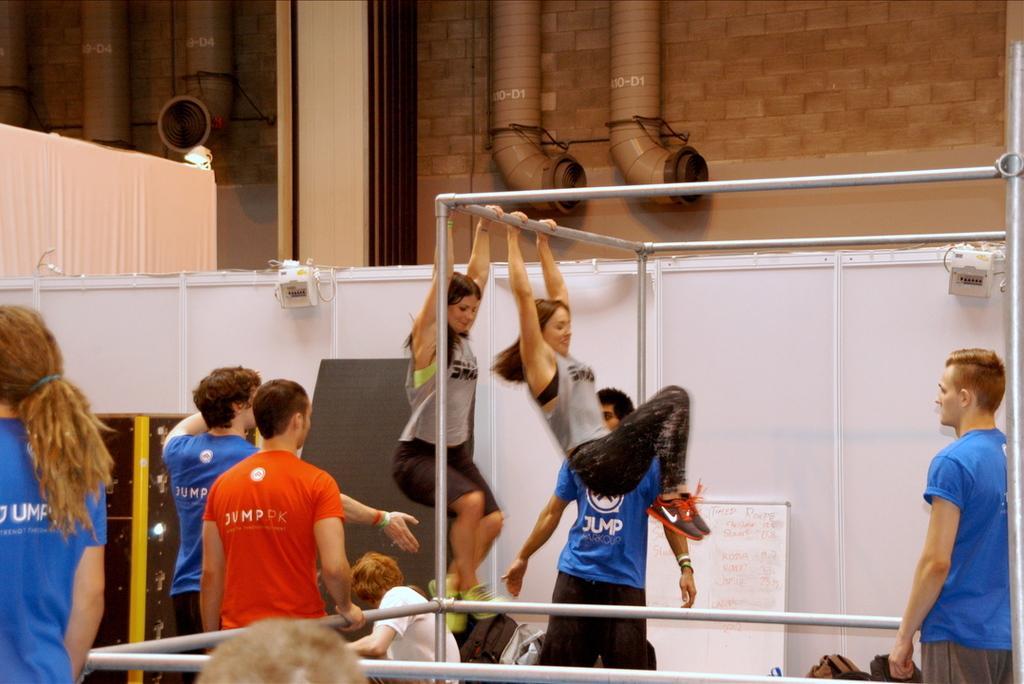Describe this image in one or two sentences. In the image there are two women doing some activity by holding rods. Around the women there are some other people,in the background there is a wall and there are four pipes attached to the wall. 